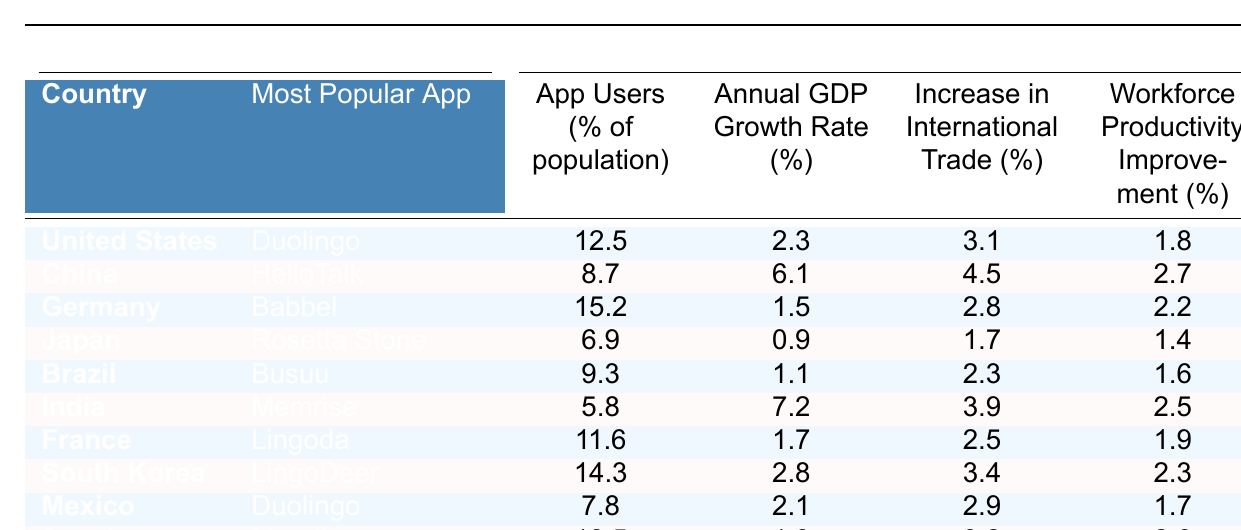What is the most popular language app in Germany? From the table, Germany's most popular app is listed as Babbel.
Answer: Babbel What percentage of the population in China uses a language app? According to the table, the percentage of app users in China is 8.7%.
Answer: 8.7% What is the GDP growth rate for India? The table shows India's annual GDP growth rate is 7.2%.
Answer: 7.2% Which country has the highest percentage of app users? By inspecting the data, Sweden has the highest percentage of app users at 18.5%.
Answer: 18.5% Calculate the average increase in international trade percentage. To find the average, sum the increase in international trade percentages (3.1 + 4.5 + 2.8 + 1.7 + 2.3 + 3.9 + 2.5 + 3.4 + 2.9 + 3.2) which equals 30.1, then divide by 10 gives 30.1/10 = 3.01.
Answer: 3.01 Which country shows no increase in workforce productivity despite a high percentage of app users? Japan, with 6.9% app users, has a workforce productivity improvement of only 1.4%, which is relatively low compared to others with similar usage.
Answer: Japan Is there a positive correlation between app users and GDP growth rate in the table? Analyzing the data does not show a clear positive correlation, as some countries with higher app users like Germany exhibit low GDP growth.
Answer: No What is the difference in GDP growth rate between China and Germany? The GDP growth rate for China is 6.1% and for Germany it is 1.5%. The difference is 6.1% - 1.5% = 4.6%.
Answer: 4.6% Which countries have a GDP growth rate greater than 2%? From the table, the countries with GDP growth rates greater than 2% are China (6.1%), India (7.2%), and South Korea (2.8%).
Answer: China, India, South Korea What can you infer about the relationship between the most popular app and international trade increase? The table presents mixed results; for example, China uses HelloTalk but has the highest trade increase, while Germany uses Babbel but has a lower increase compared to others. Thus, there's no definitive relationship.
Answer: No definitive relationship 